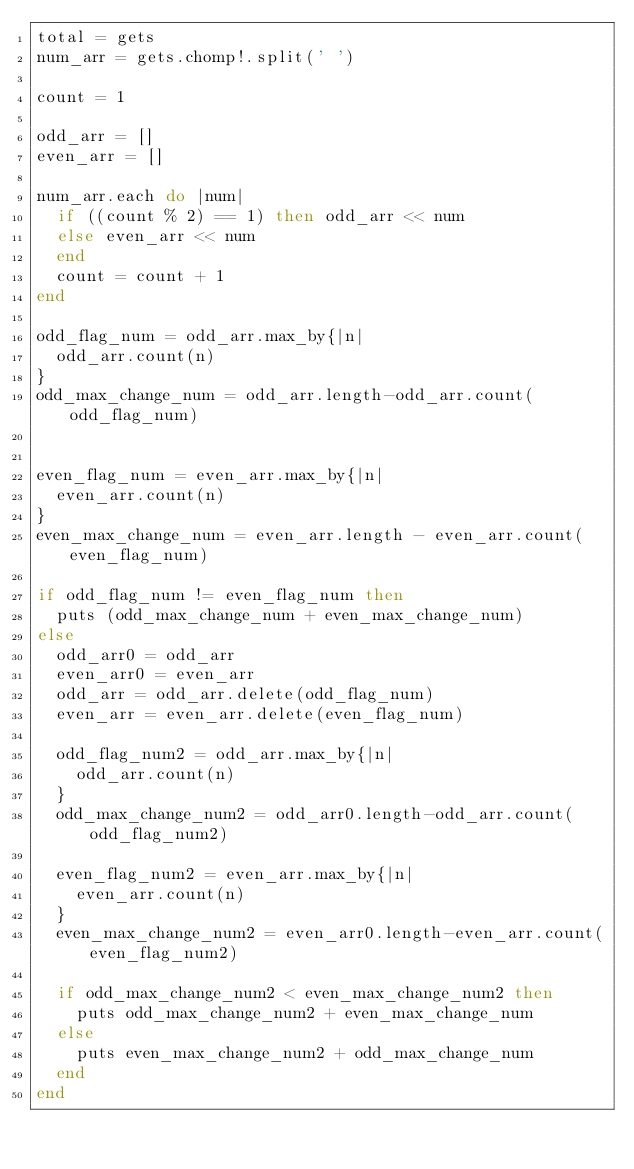<code> <loc_0><loc_0><loc_500><loc_500><_Ruby_>total = gets
num_arr = gets.chomp!.split(' ')

count = 1

odd_arr = []
even_arr = []

num_arr.each do |num|
  if ((count % 2) == 1) then odd_arr << num
  else even_arr << num
  end
  count = count + 1
end

odd_flag_num = odd_arr.max_by{|n|
  odd_arr.count(n)
}
odd_max_change_num = odd_arr.length-odd_arr.count(odd_flag_num)


even_flag_num = even_arr.max_by{|n|
  even_arr.count(n)
}
even_max_change_num = even_arr.length - even_arr.count(even_flag_num)

if odd_flag_num != even_flag_num then
  puts (odd_max_change_num + even_max_change_num)
else
  odd_arr0 = odd_arr
  even_arr0 = even_arr
  odd_arr = odd_arr.delete(odd_flag_num)
  even_arr = even_arr.delete(even_flag_num)

  odd_flag_num2 = odd_arr.max_by{|n|
    odd_arr.count(n)
  }
  odd_max_change_num2 = odd_arr0.length-odd_arr.count(odd_flag_num2)

  even_flag_num2 = even_arr.max_by{|n|
    even_arr.count(n)
  }
  even_max_change_num2 = even_arr0.length-even_arr.count(even_flag_num2)

  if odd_max_change_num2 < even_max_change_num2 then
    puts odd_max_change_num2 + even_max_change_num
  else
    puts even_max_change_num2 + odd_max_change_num
  end
end</code> 